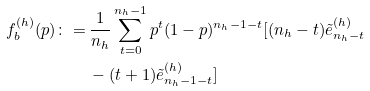Convert formula to latex. <formula><loc_0><loc_0><loc_500><loc_500>f _ { b } ^ { ( h ) } ( p ) \colon = & \, \frac { 1 } { n _ { h } } \sum _ { t = 0 } ^ { n _ { h } - 1 } p ^ { t } ( 1 - p ) ^ { n _ { h } - 1 - t } [ ( n _ { h } - t ) \tilde { e } ^ { ( h ) } _ { n _ { h } - t } \\ & \, - ( t + 1 ) \tilde { e } ^ { ( h ) } _ { n _ { h } - 1 - t } ]</formula> 